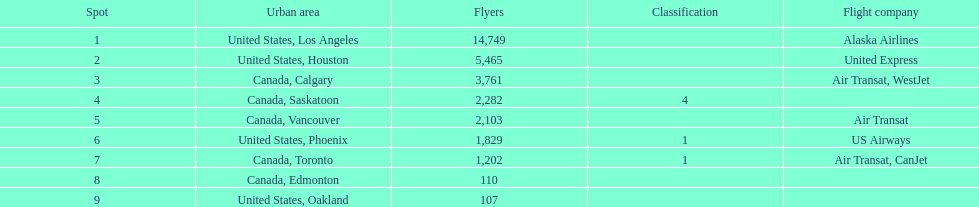What was the number of passengers in phoenix arizona? 1,829. Parse the table in full. {'header': ['Spot', 'Urban area', 'Flyers', 'Classification', 'Flight company'], 'rows': [['1', 'United States, Los Angeles', '14,749', '', 'Alaska Airlines'], ['2', 'United States, Houston', '5,465', '', 'United Express'], ['3', 'Canada, Calgary', '3,761', '', 'Air Transat, WestJet'], ['4', 'Canada, Saskatoon', '2,282', '4', ''], ['5', 'Canada, Vancouver', '2,103', '', 'Air Transat'], ['6', 'United States, Phoenix', '1,829', '1', 'US Airways'], ['7', 'Canada, Toronto', '1,202', '1', 'Air Transat, CanJet'], ['8', 'Canada, Edmonton', '110', '', ''], ['9', 'United States, Oakland', '107', '', '']]} 